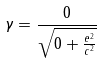Convert formula to latex. <formula><loc_0><loc_0><loc_500><loc_500>\gamma = \frac { 0 } { \sqrt { 0 + \frac { e ^ { 2 } } { c ^ { 2 } } } }</formula> 